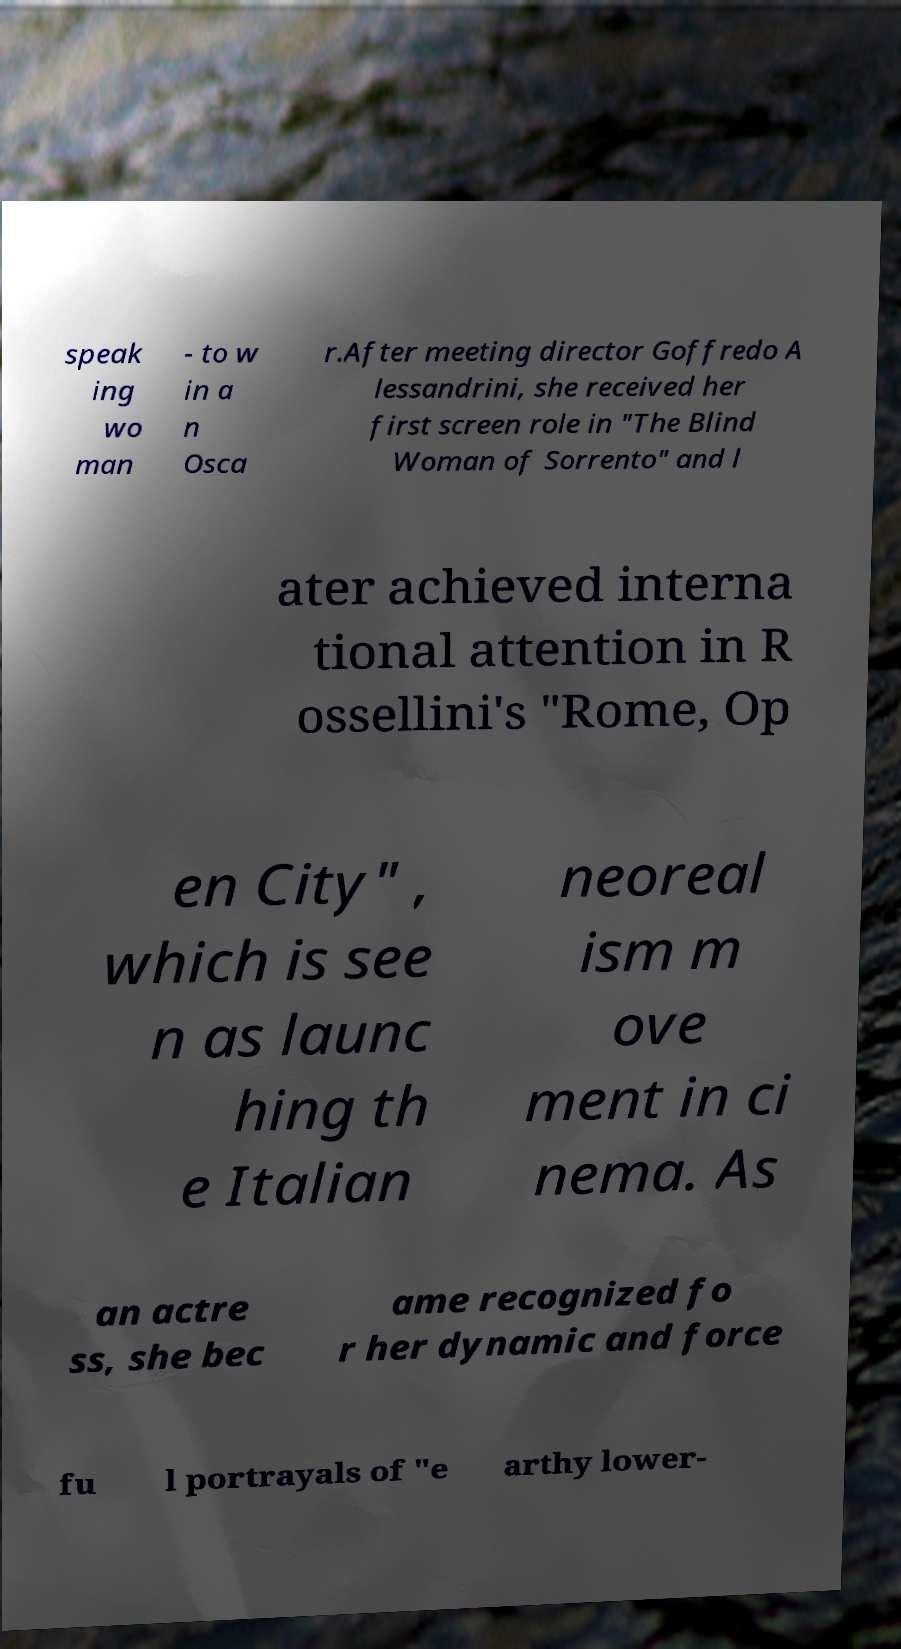Could you assist in decoding the text presented in this image and type it out clearly? speak ing wo man - to w in a n Osca r.After meeting director Goffredo A lessandrini, she received her first screen role in "The Blind Woman of Sorrento" and l ater achieved interna tional attention in R ossellini's "Rome, Op en City" , which is see n as launc hing th e Italian neoreal ism m ove ment in ci nema. As an actre ss, she bec ame recognized fo r her dynamic and force fu l portrayals of "e arthy lower- 